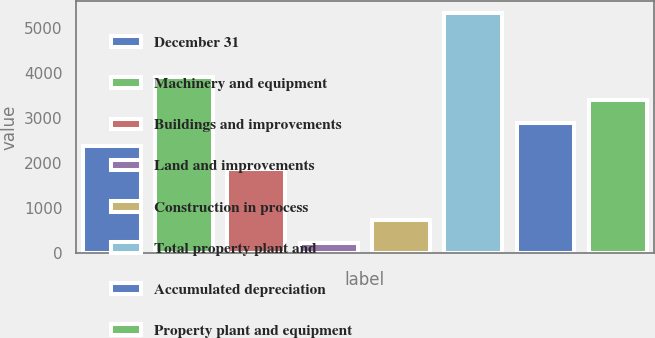Convert chart. <chart><loc_0><loc_0><loc_500><loc_500><bar_chart><fcel>December 31<fcel>Machinery and equipment<fcel>Buildings and improvements<fcel>Land and improvements<fcel>Construction in process<fcel>Total property plant and<fcel>Accumulated depreciation<fcel>Property plant and equipment<nl><fcel>2374.3<fcel>3908.2<fcel>1863<fcel>227<fcel>738.3<fcel>5340<fcel>2885.6<fcel>3396.9<nl></chart> 